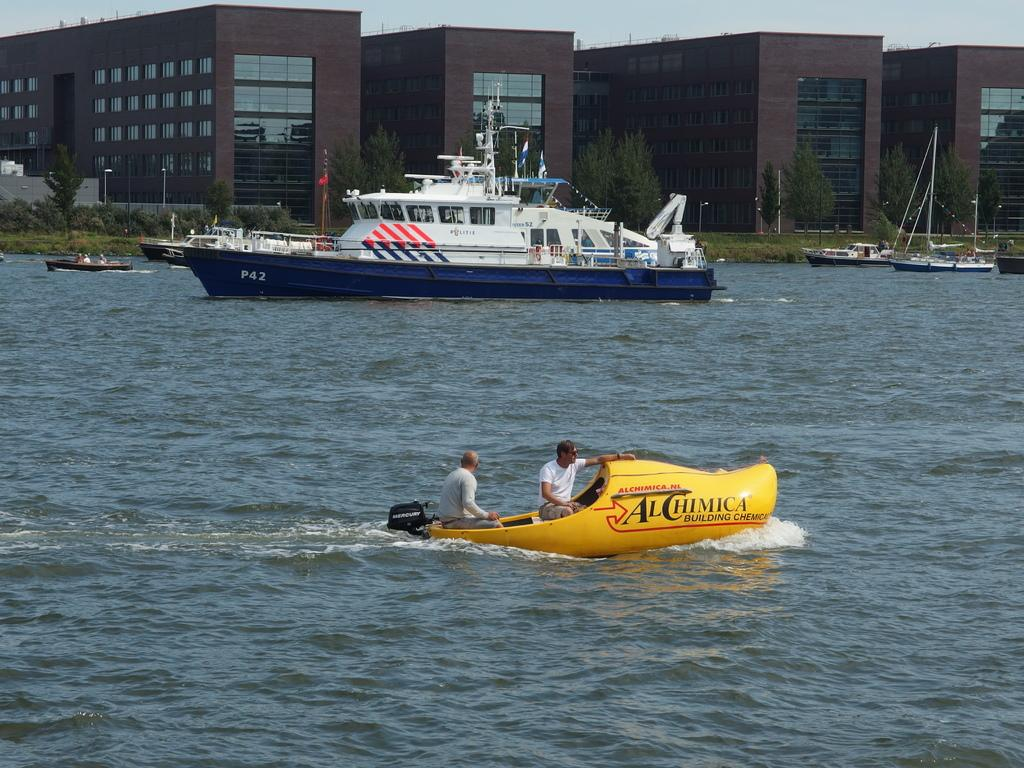What are the people in the image doing? The people in the image are sitting in a boat. What else can be seen in the water near the boat? There is a ship beside the boat. What can be seen in the distance in the image? There are buildings and trees visible in the background of the image. What type of help can be seen on the stage in the image? There is no stage present in the image, so it is not possible to determine what type of help might be seen on a stage. 